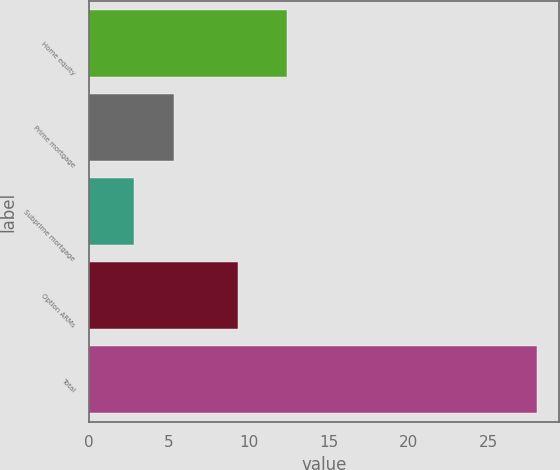Convert chart. <chart><loc_0><loc_0><loc_500><loc_500><bar_chart><fcel>Home equity<fcel>Prime mortgage<fcel>Subprime mortgage<fcel>Option ARMs<fcel>Total<nl><fcel>12.4<fcel>5.32<fcel>2.8<fcel>9.3<fcel>28<nl></chart> 